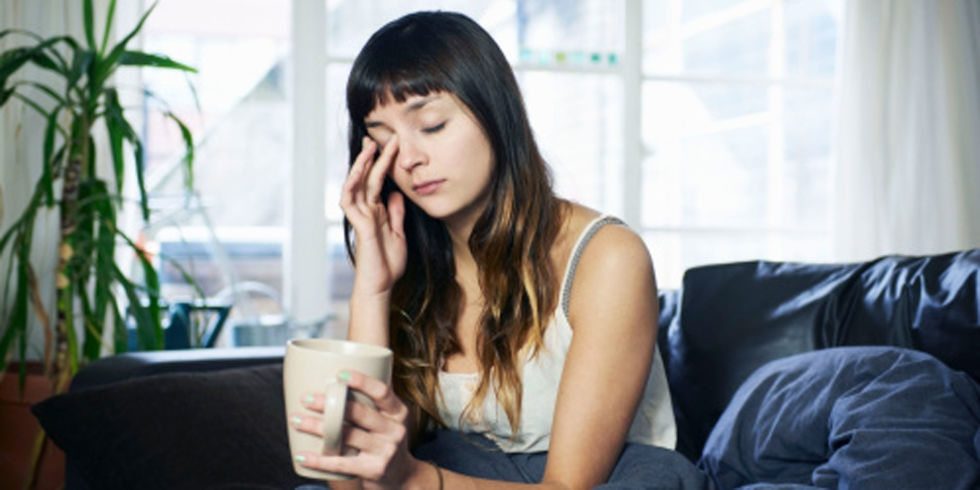How might the person in the image be feeling, based on her body language and facial expression? The woman in the image seems to be experiencing a moment of fatigue or stress, as indicated by her closed eyes and the hand on her forehead. Her slight frown and the way she's holding her cup suggest she's taking a moment to rest or reflect. What time of day does it seem to be in the image? Considering the natural light present in the room and the overall calm atmosphere, it could be morning or afternoon. The quality of the light suggests it's not the peak hours of the day when the sunlight is at its brightest. 